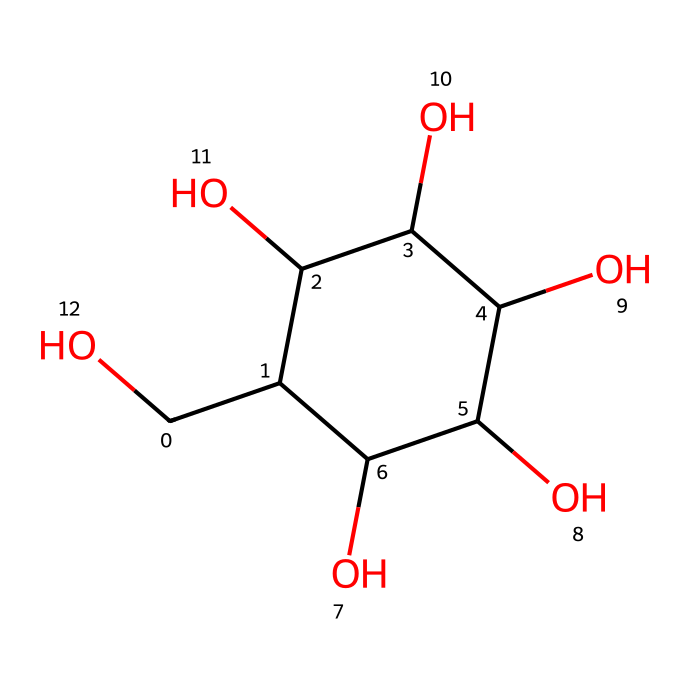What is the molecular formula of glucose? Based on the SMILES representation, counting the atoms gives us 6 carbon atoms (C), 12 hydrogen atoms (H), and 6 oxygen atoms (O). Therefore, the molecular formula can be deduced.
Answer: C6H12O6 How many hydroxyl (-OH) groups are present in glucose? Analyzing the chemical structure, each hydroxyl group corresponds to an -OH attached to the carbon atoms. By examining the structure, we can see there are 5 -OH groups.
Answer: 5 What type of isomerism does glucose exhibit? Glucose can exist in two forms: α-D-glucose and β-D-glucose due to the configuration around the anomeric carbon (C1). Thus, it exhibits anomeric isomerism.
Answer: anomeric Is glucose soluble in water? Glucose is a polar molecule due to its numerous -OH groups, which allows it to interact with water molecules and dissolve readily.
Answer: yes What impact does glucose have on urban waste management? Glucose, being a biodegradable sugar, can be broken down by microorganisms in composting processes, contributing to the recycling of organic matter.
Answer: contributes to recycling What type of compound is glucose classified as in terms of electrolytic properties? Glucose is a non-electrolyte because it does not dissociate into ions when dissolved in water. This is evident from its SMILES structure, which lacks ionizable groups.
Answer: non-electrolyte How does glucose contribute to the energy needs of microorganisms during waste decomposition? Glucose serves as a primary source of energy for many microorganisms in urban waste management, providing the necessary fuel for their metabolic processes.
Answer: primary energy source 